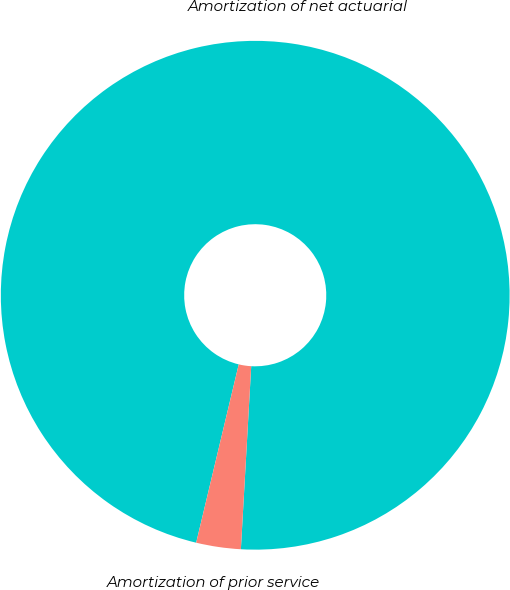Convert chart. <chart><loc_0><loc_0><loc_500><loc_500><pie_chart><fcel>Amortization of net actuarial<fcel>Amortization of prior service<nl><fcel>97.17%<fcel>2.83%<nl></chart> 